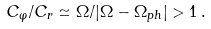<formula> <loc_0><loc_0><loc_500><loc_500>C _ { \varphi } / C _ { r } \simeq \Omega / | \Omega - \Omega _ { p h } | > 1 \, .</formula> 